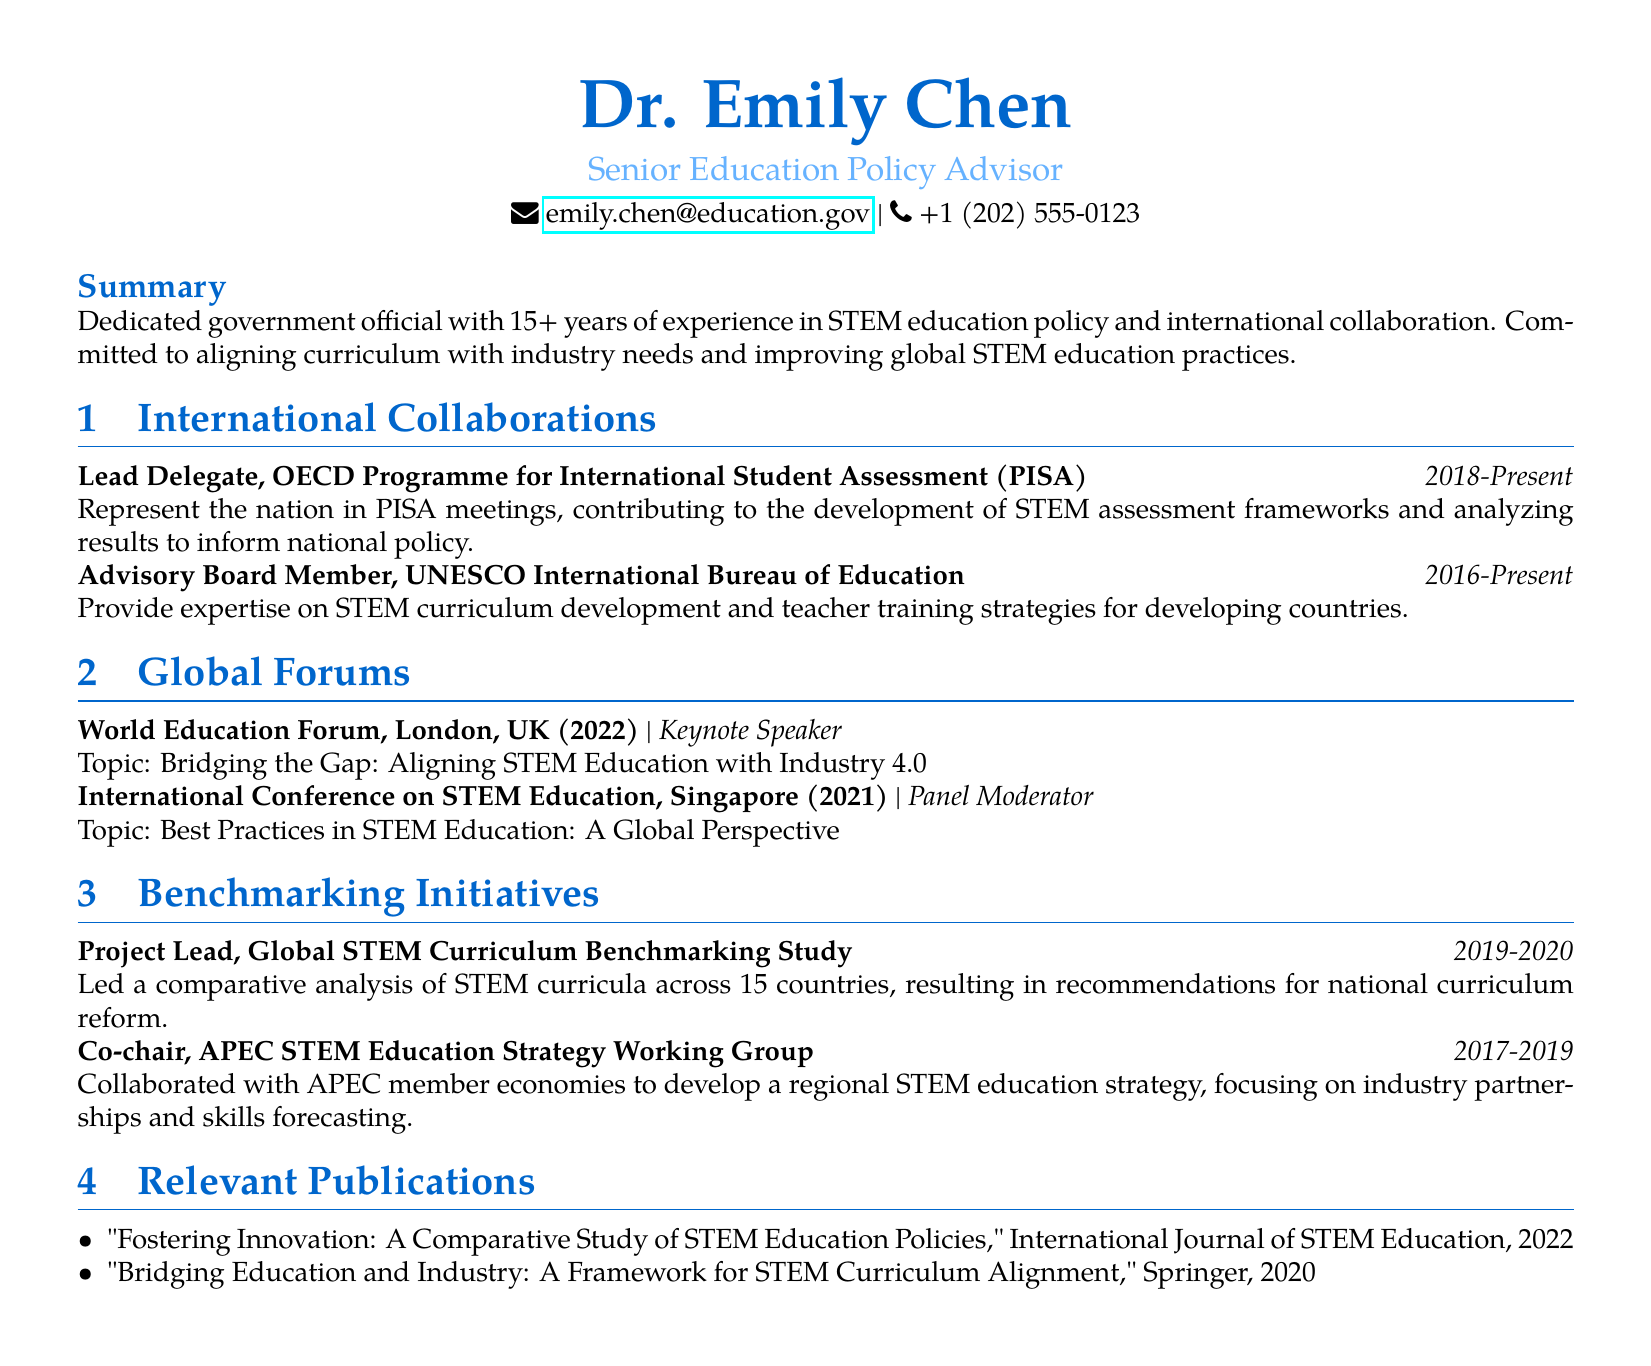what is the name of the senior education policy advisor? The name provided in the document is Dr. Emily Chen.
Answer: Dr. Emily Chen what is the duration of Dr. Emily Chen's role as lead delegate for PISA? The document states that she has held this position from 2018 to the present.
Answer: 2018-Present what major global forum did Dr. Emily Chen speak at in London? The document lists the World Education Forum, where she was a keynote speaker.
Answer: World Education Forum what project did Dr. Emily Chen lead from 2019 to 2020? The document mentions her as Project Lead for the Global STEM Curriculum Benchmarking Study during this period.
Answer: Global STEM Curriculum Benchmarking Study how many countries were included in the comparative analysis of the Global STEM Curriculum Benchmarking Study? The document specifies that 15 countries were included in this analysis.
Answer: 15 what is the focus of the APEC STEM Education Strategy Working Group? According to the document, it focuses on industry partnerships and skills forecasting.
Answer: Industry partnerships and skills forecasting which journal published Dr. Chen's work titled "Fostering Innovation"? The document indicates that this publication appeared in the International Journal of STEM Education.
Answer: International Journal of STEM Education what is one of the main responsibilities of Dr. Chen as an advisory board member at UNESCO? The document states she provides expertise on STEM curriculum development and teacher training strategies.
Answer: Expertise on STEM curriculum development and teacher training strategies 